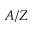Convert formula to latex. <formula><loc_0><loc_0><loc_500><loc_500>A / Z</formula> 